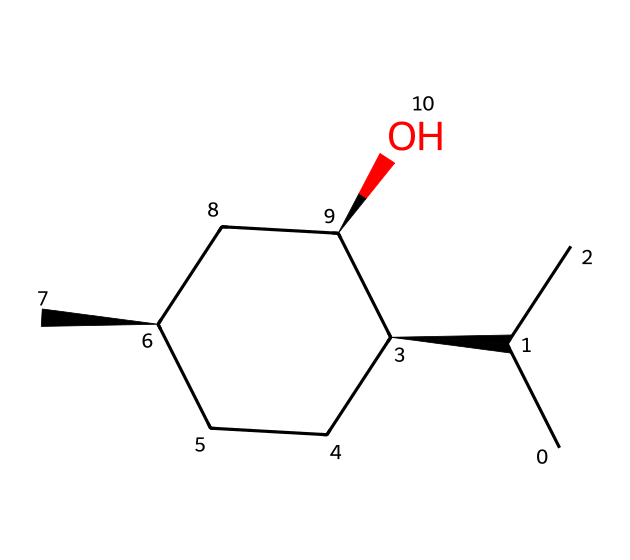What is the name of this chiral compound? The SMILES representation provided corresponds to menthol, which is a recognized chiral compound commonly used in various applications, including cooling materials.
Answer: menthol How many carbon atoms are present in this structure? By examining the SMILES, we can count a total of 10 carbon atoms represented. Each carbon atom is typically denoted by 'C,' and by visualizing the structure or interpreting from the SMILES, we find 10 in total.
Answer: 10 How many stereocenters are in this compound? A stereocenter is identified where a carbon atom is attached to four different substituents. In this structure, there are three stereocenters indicated by the '@' symbols in the SMILES representation, defining specific 3D arrangements.
Answer: 3 What is the primary functional group in menthol? The SMILES notation includes 'O,' indicating the presence of a hydroxyl (alcohol) functional group, which is characteristic in menthol. This hydroxyl group gives menthol its typical properties.
Answer: hydroxyl What type of isomerism does menthol exhibit? Since menthol has multiple stereocenters, it exhibits optical isomerism, allowing for the presence of enantiomers (mirror-image isomers) due to the chiral nature of its configuration.
Answer: optical isomerism How does menthol contribute to cooling sensations? Menthol activates the TRPM8 receptor, which is responsible for detecting cool temperatures, leading to a cooling sensation. This is due to its molecular structure interacting with sensory receptors, confirmed through analysis of its configuration and functional properties in the chemical realm.
Answer: TRPM8 receptor 